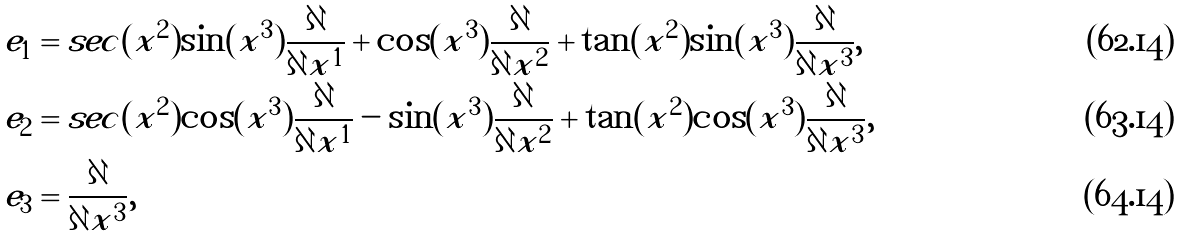<formula> <loc_0><loc_0><loc_500><loc_500>e _ { 1 } & = s e c ( x ^ { 2 } ) \sin ( x ^ { 3 } ) \frac { \partial } { \partial x ^ { 1 } } + \cos ( x ^ { 3 } ) \frac { \partial } { \partial x ^ { 2 } } + \tan ( x ^ { 2 } ) \sin ( x ^ { 3 } ) \frac { \partial } { \partial x ^ { 3 } } , \\ e _ { 2 } & = s e c ( x ^ { 2 } ) \cos ( x ^ { 3 } ) \frac { \partial } { \partial x ^ { 1 } } - \sin ( x ^ { 3 } ) \frac { \partial } { \partial x ^ { 2 } } + \tan ( x ^ { 2 } ) \cos ( x ^ { 3 } ) \frac { \partial } { \partial x ^ { 3 } } , \\ e _ { 3 } & = \frac { \partial } { \partial x ^ { 3 } } ,</formula> 